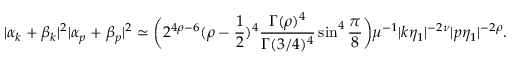Convert formula to latex. <formula><loc_0><loc_0><loc_500><loc_500>| \alpha _ { k } + \beta _ { k } | ^ { 2 } | \alpha _ { p } + \beta _ { p } | ^ { 2 } \simeq \left ( 2 ^ { 4 \rho - 6 } ( \rho - \frac { 1 } { 2 } ) ^ { 4 } \frac { \Gamma ( \rho ) ^ { 4 } } { \Gamma ( 3 / 4 ) ^ { 4 } } \sin ^ { 4 } { \frac { \pi } { 8 } } \right ) \mu ^ { - 1 } | k \eta _ { 1 } | ^ { - 2 \nu } | p \eta _ { 1 } | ^ { - 2 \rho } .</formula> 